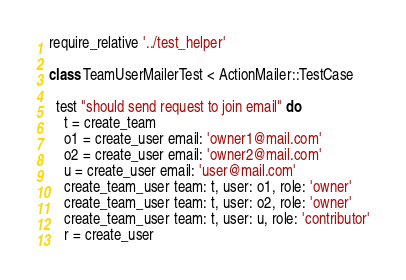Convert code to text. <code><loc_0><loc_0><loc_500><loc_500><_Ruby_>require_relative '../test_helper'

class TeamUserMailerTest < ActionMailer::TestCase

  test "should send request to join email" do
    t = create_team
    o1 = create_user email: 'owner1@mail.com'
    o2 = create_user email: 'owner2@mail.com'
    u = create_user email: 'user@mail.com'
    create_team_user team: t, user: o1, role: 'owner'
    create_team_user team: t, user: o2, role: 'owner'
    create_team_user team: t, user: u, role: 'contributor'
    r = create_user
</code> 